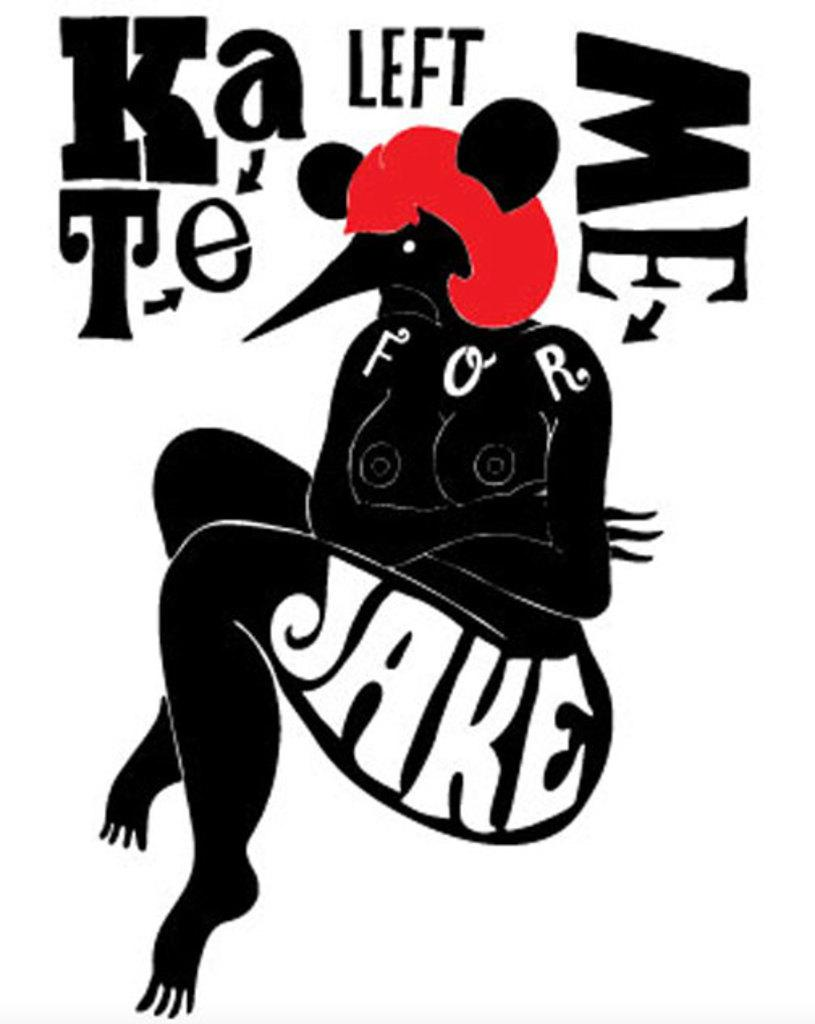What type of subject is depicted in the image? The image is an animated human. Are there any words or phrases in the image? Yes, there is text present in the image. What type of space exploration is the beetle involved in within the image? There is no beetle present in the image, and therefore no space exploration can be observed. 